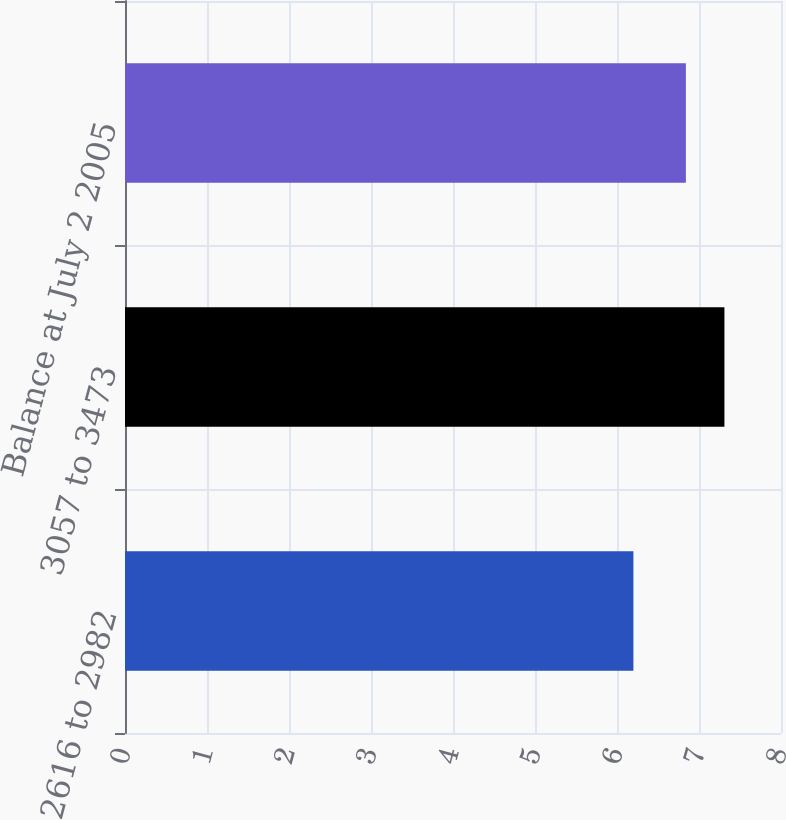Convert chart. <chart><loc_0><loc_0><loc_500><loc_500><bar_chart><fcel>2616 to 2982<fcel>3057 to 3473<fcel>Balance at July 2 2005<nl><fcel>6.2<fcel>7.31<fcel>6.84<nl></chart> 